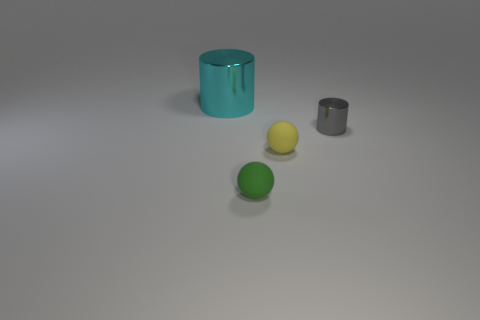Is there any other thing that has the same size as the cyan cylinder?
Make the answer very short. No. What material is the large object that is the same shape as the small shiny object?
Keep it short and to the point. Metal. How many matte objects are either tiny green cubes or big objects?
Offer a terse response. 0. The gray thing that is made of the same material as the cyan cylinder is what shape?
Provide a short and direct response. Cylinder. What number of other cyan metallic objects have the same shape as the large cyan thing?
Provide a short and direct response. 0. Is the shape of the metallic thing left of the gray metallic object the same as the metal object to the right of the green object?
Give a very brief answer. Yes. How many objects are big red rubber blocks or cylinders to the left of the small green rubber thing?
Make the answer very short. 1. How many gray metal things have the same size as the gray cylinder?
Give a very brief answer. 0. How many cyan objects are either large metallic things or small matte things?
Your response must be concise. 1. There is a matte thing that is to the left of the small matte thing that is behind the tiny green sphere; what is its shape?
Your response must be concise. Sphere. 